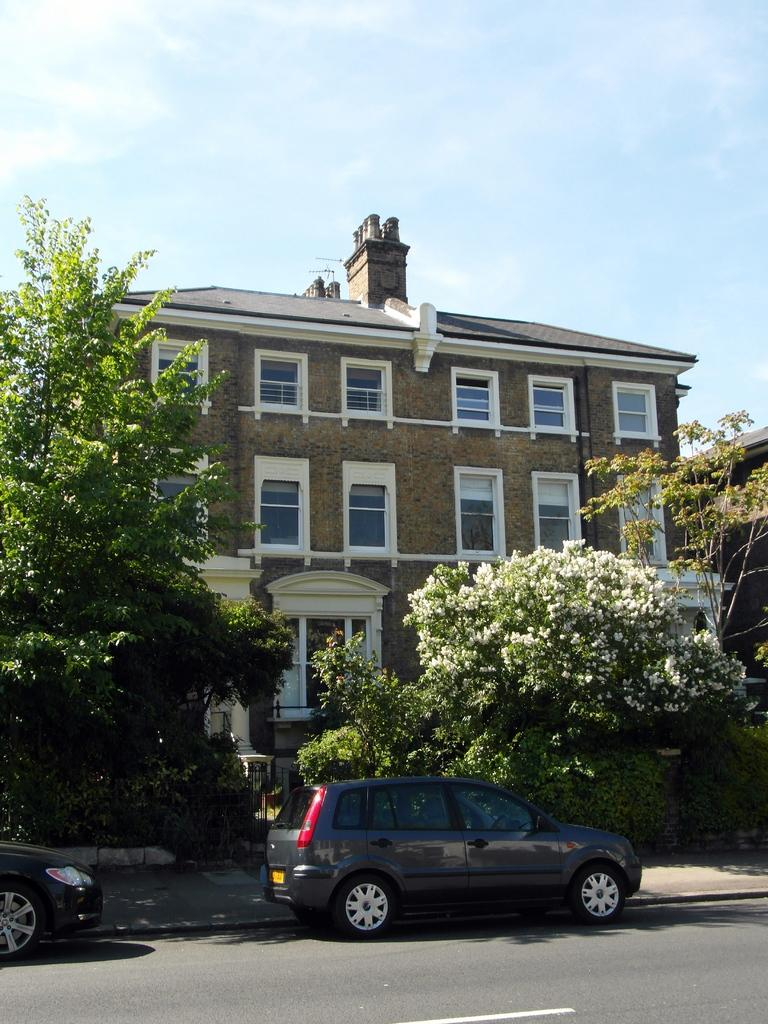What type of structure is present in the image? There is a house in the image. What can be seen in front of the house? There are many trees in front of the house. What else is visible in the image besides the house and trees? There are vehicles visible on the road. What is the color of the sky in the image? The sky is blue in the image. What type of screw can be seen holding the house together in the image? There is no screw visible in the image, as it is a photograph of a house and not a detailed illustration of its construction. 